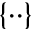<formula> <loc_0><loc_0><loc_500><loc_500>\{ \cdot \cdot \}</formula> 